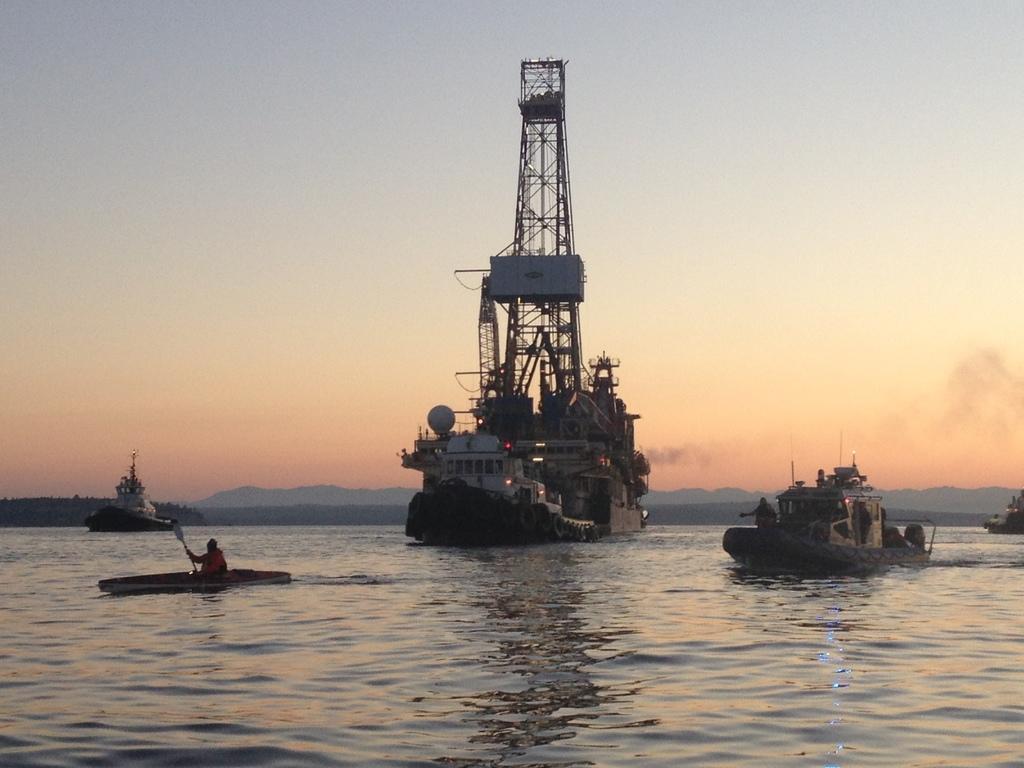In one or two sentences, can you explain what this image depicts? In this picture I can see boat, ships in the water, hills and sky. 